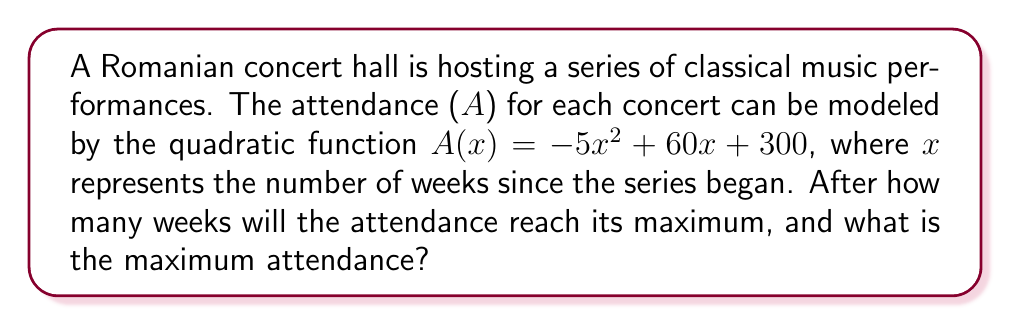Show me your answer to this math problem. To solve this problem, we'll follow these steps:

1) For a quadratic function in the form $f(x) = ax^2 + bx + c$, the x-coordinate of the vertex represents the point where the function reaches its maximum (if $a < 0$) or minimum (if $a > 0$).

2) The formula for the x-coordinate of the vertex is $x = -\frac{b}{2a}$.

3) In our function $A(x) = -5x^2 + 60x + 300$, we have:
   $a = -5$
   $b = 60$
   $c = 300$

4) Plugging into the formula:
   $x = -\frac{60}{2(-5)} = -\frac{60}{-10} = 6$

5) This means the attendance will reach its maximum after 6 weeks.

6) To find the maximum attendance, we substitute x = 6 into the original function:

   $A(6) = -5(6)^2 + 60(6) + 300$
   $    = -5(36) + 360 + 300$
   $    = -180 + 360 + 300$
   $    = 480$

Therefore, the maximum attendance will be 480 people.
Answer: 6 weeks; 480 people 